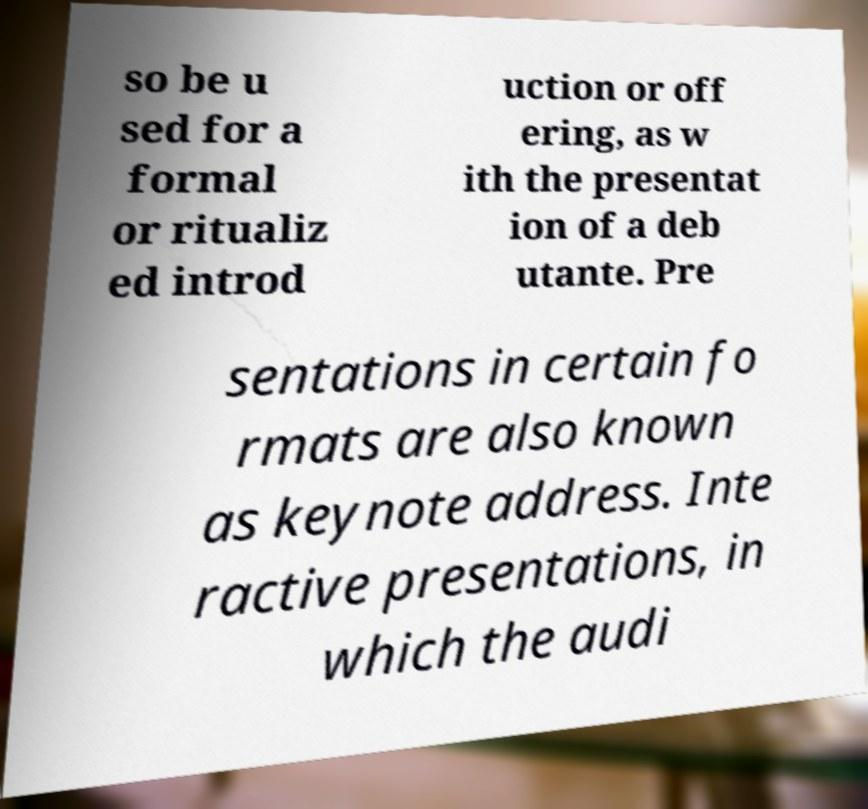There's text embedded in this image that I need extracted. Can you transcribe it verbatim? so be u sed for a formal or ritualiz ed introd uction or off ering, as w ith the presentat ion of a deb utante. Pre sentations in certain fo rmats are also known as keynote address. Inte ractive presentations, in which the audi 